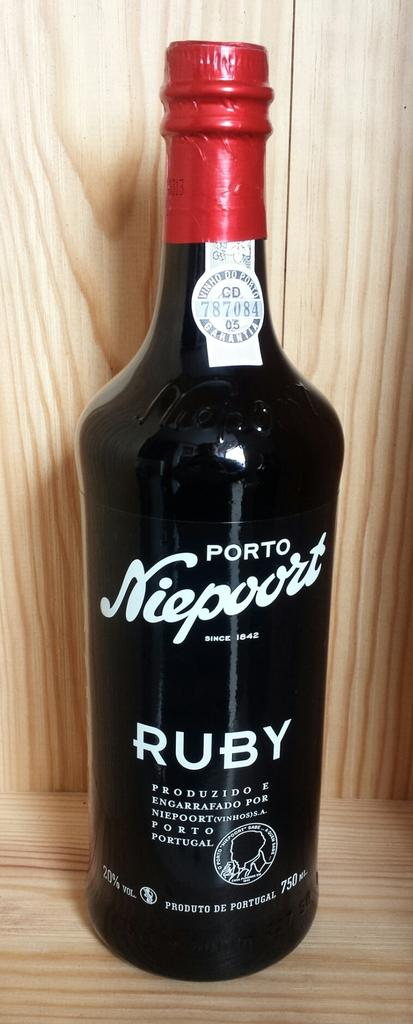<image>
Share a concise interpretation of the image provided. A body of Porto Niepoort with a red cover over the screw top. 